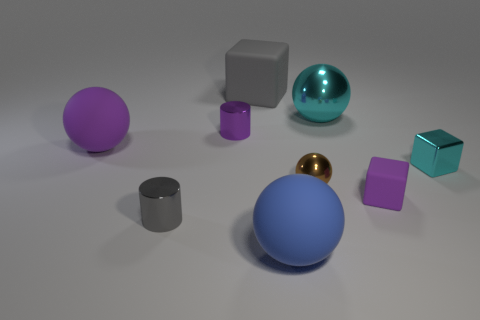Subtract all small metal balls. How many balls are left? 3 Add 1 big purple matte balls. How many objects exist? 10 Subtract all purple cylinders. How many cylinders are left? 1 Subtract all balls. How many objects are left? 5 Add 8 purple cubes. How many purple cubes exist? 9 Subtract 1 blue balls. How many objects are left? 8 Subtract all purple spheres. Subtract all blue cylinders. How many spheres are left? 3 Subtract all tiny red matte objects. Subtract all matte balls. How many objects are left? 7 Add 4 large cyan spheres. How many large cyan spheres are left? 5 